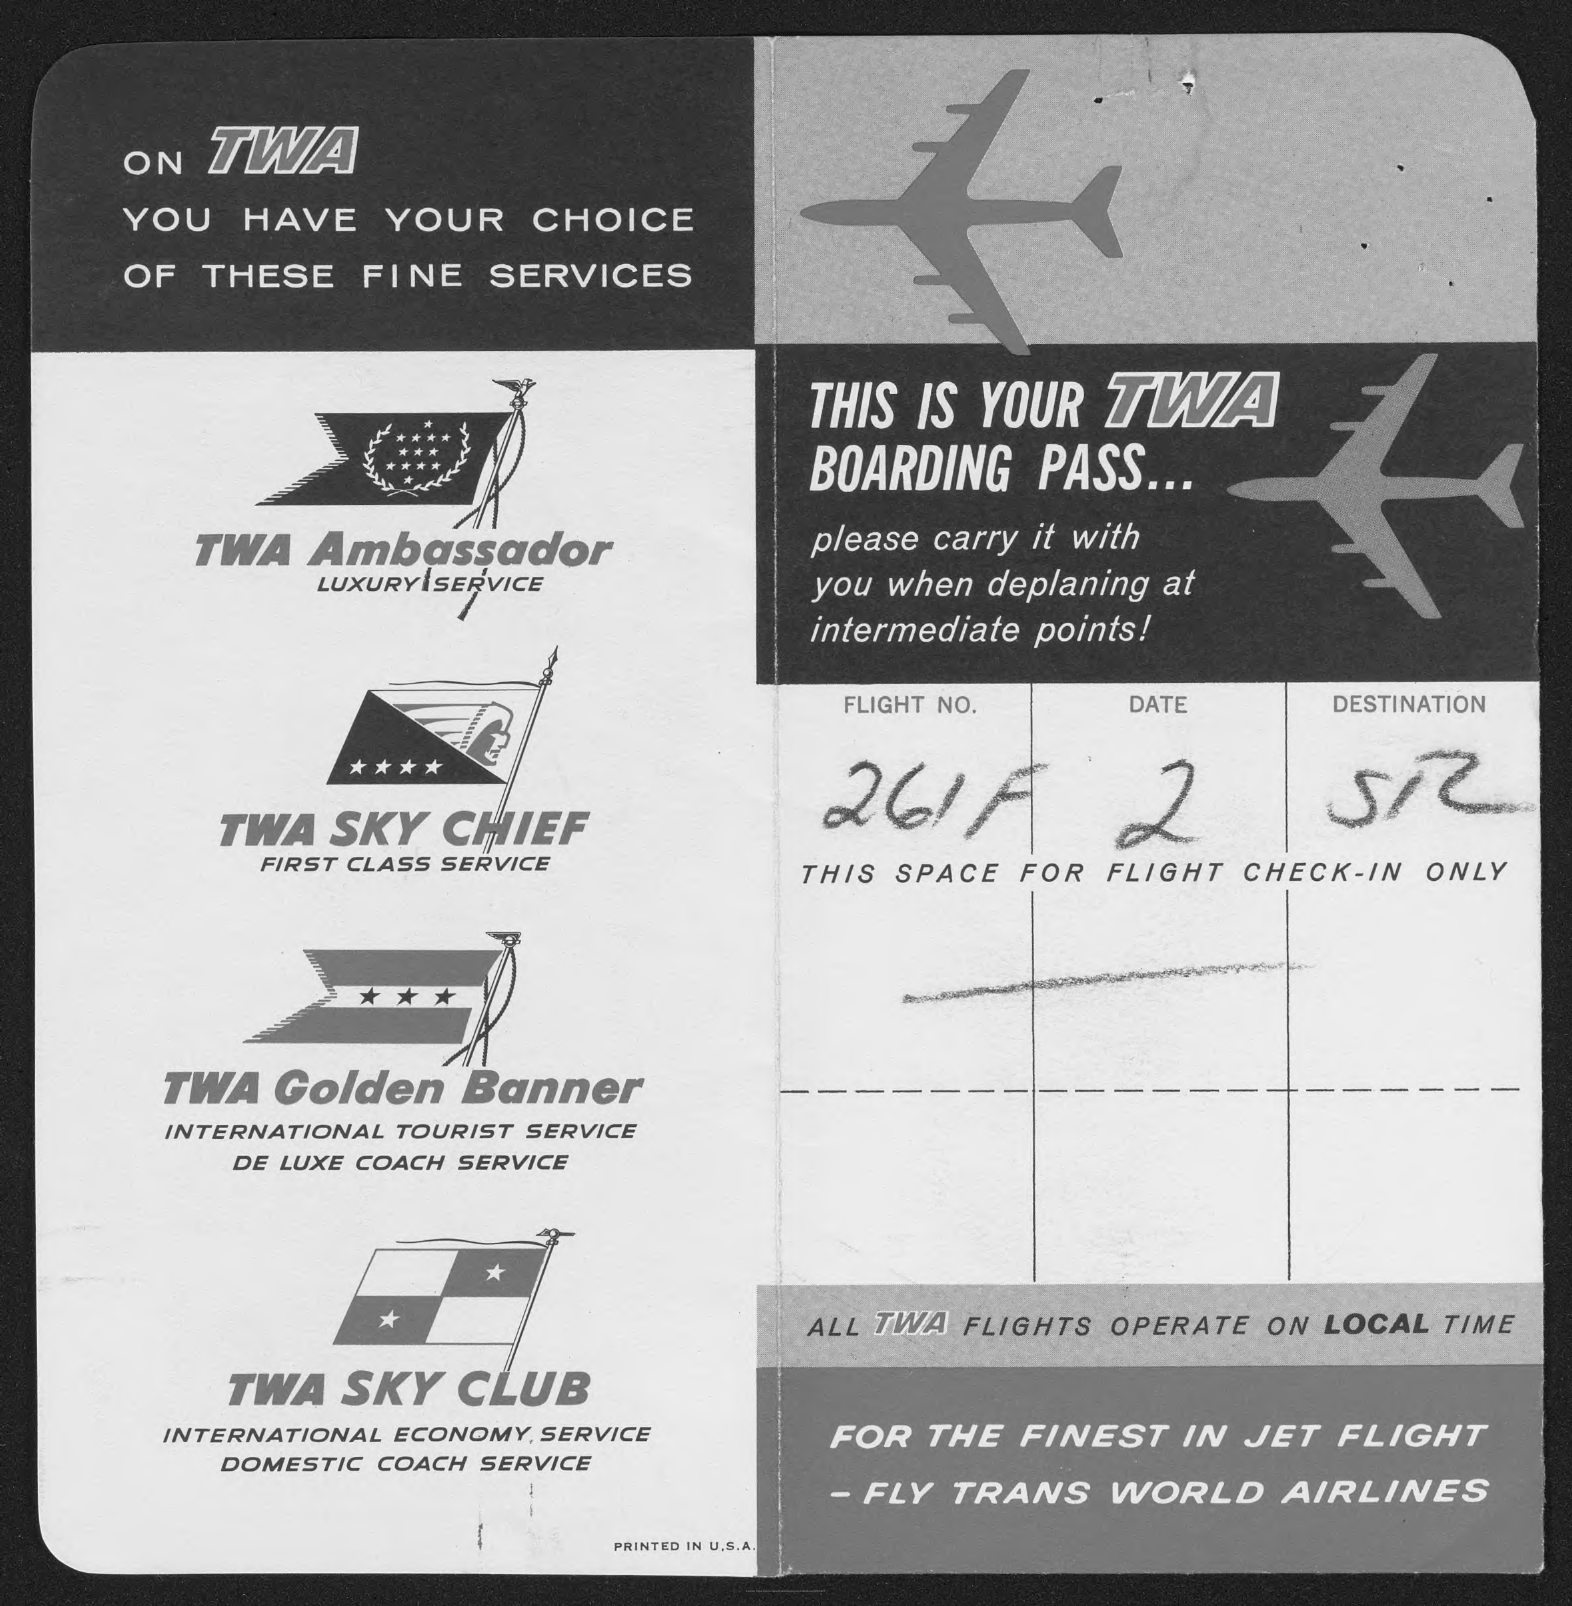What is the Flight No. given in the boarding pass?
Your response must be concise. 261F. What is the destination mentioned in the boarding pass?
Make the answer very short. SR. 